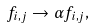<formula> <loc_0><loc_0><loc_500><loc_500>f _ { i , j } \rightarrow \alpha f _ { i , j } ,</formula> 